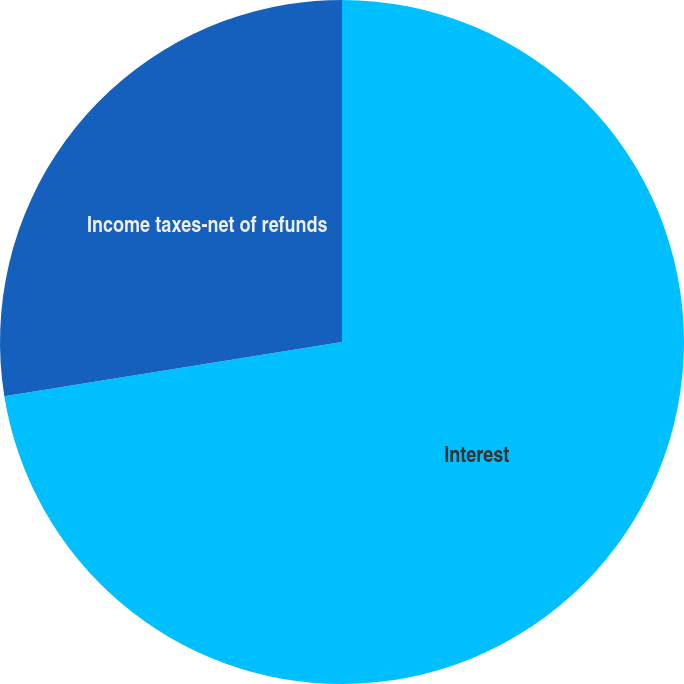<chart> <loc_0><loc_0><loc_500><loc_500><pie_chart><fcel>Interest<fcel>Income taxes-net of refunds<nl><fcel>72.47%<fcel>27.53%<nl></chart> 